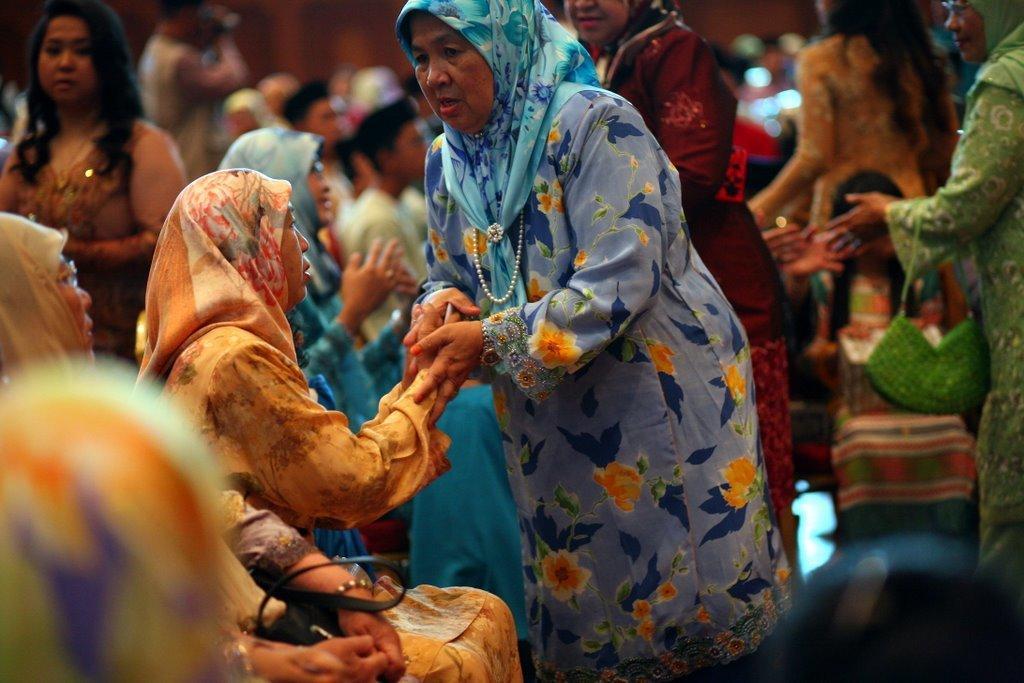Could you give a brief overview of what you see in this image? In this image I can see the group of people. And these people are wearing the different color dresses. I can see few people are sitting and few are standing. 